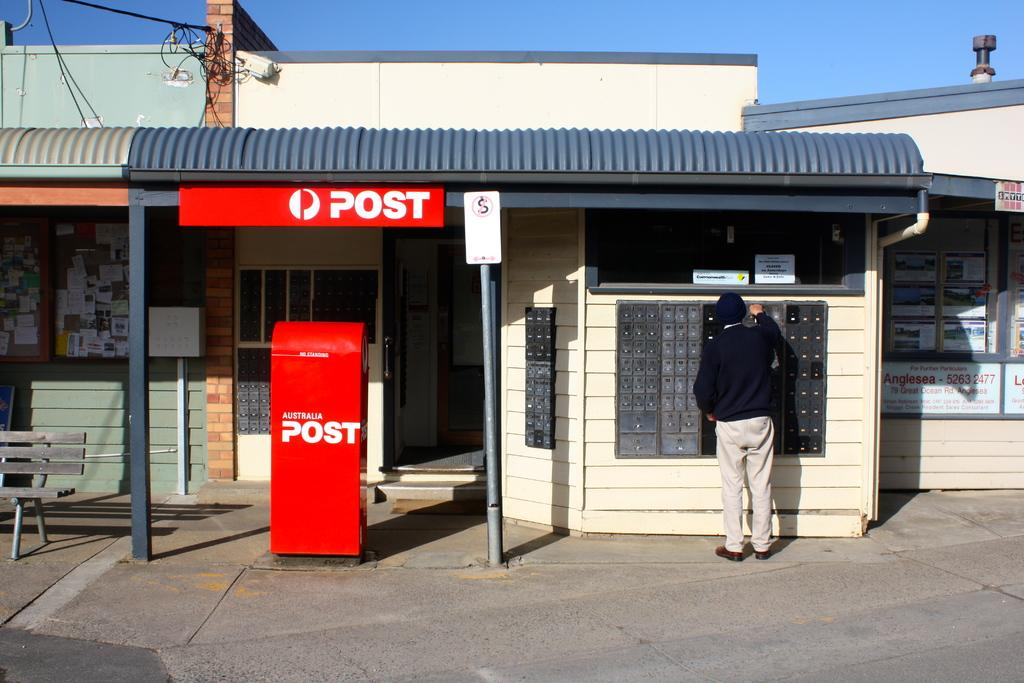What is the color of the post box in the image? The post box in the image is red. What else can be seen in the image besides the post box? There is a person standing in the image, and a building is visible in the background. What is the person wearing in the image? The person is wearing a black color T-shirt. What can be seen in the sky in the background of the image? The sky is visible in the background of the image. What type of caption is written on the squirrel in the image? There is no squirrel present in the image, and therefore no caption can be found on it. 